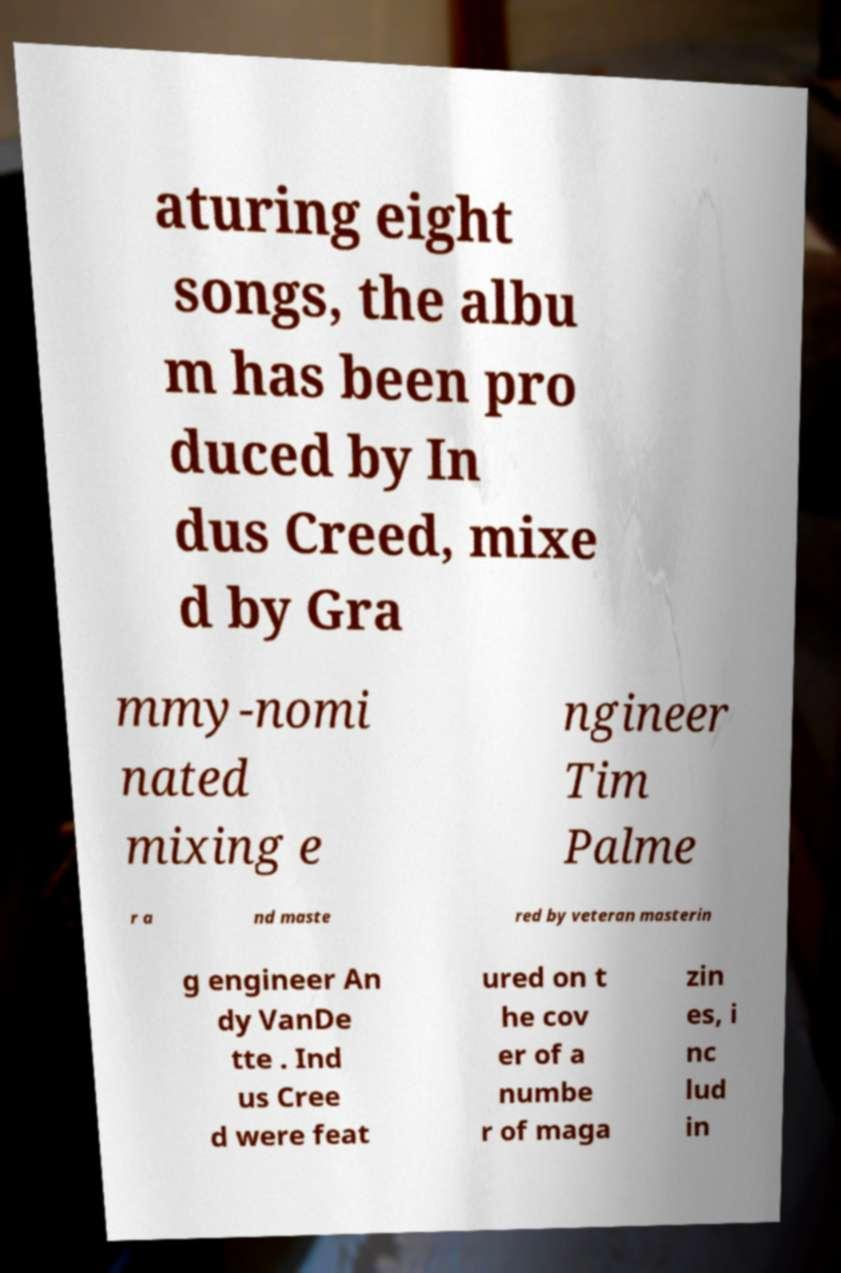There's text embedded in this image that I need extracted. Can you transcribe it verbatim? aturing eight songs, the albu m has been pro duced by In dus Creed, mixe d by Gra mmy-nomi nated mixing e ngineer Tim Palme r a nd maste red by veteran masterin g engineer An dy VanDe tte . Ind us Cree d were feat ured on t he cov er of a numbe r of maga zin es, i nc lud in 